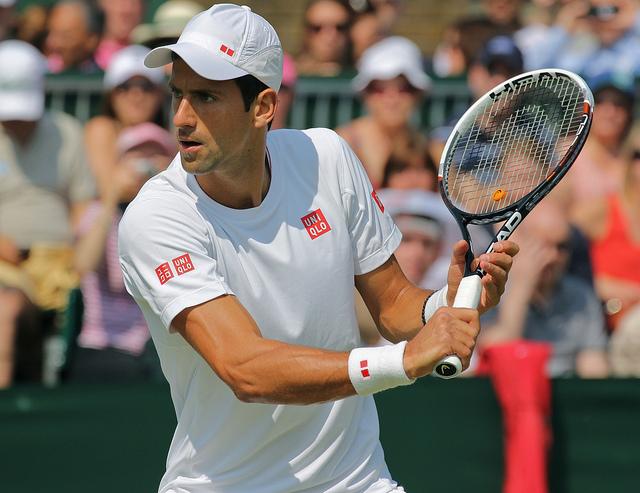What sport is this man playing?
Give a very brief answer. Tennis. What color is the logo on the man's shirt?
Quick response, please. Red. Are all the spectators wearing hats?
Concise answer only. No. 